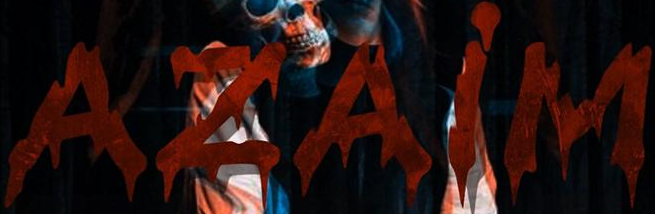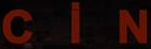Transcribe the words shown in these images in order, separated by a semicolon. AZAiM; CiN 